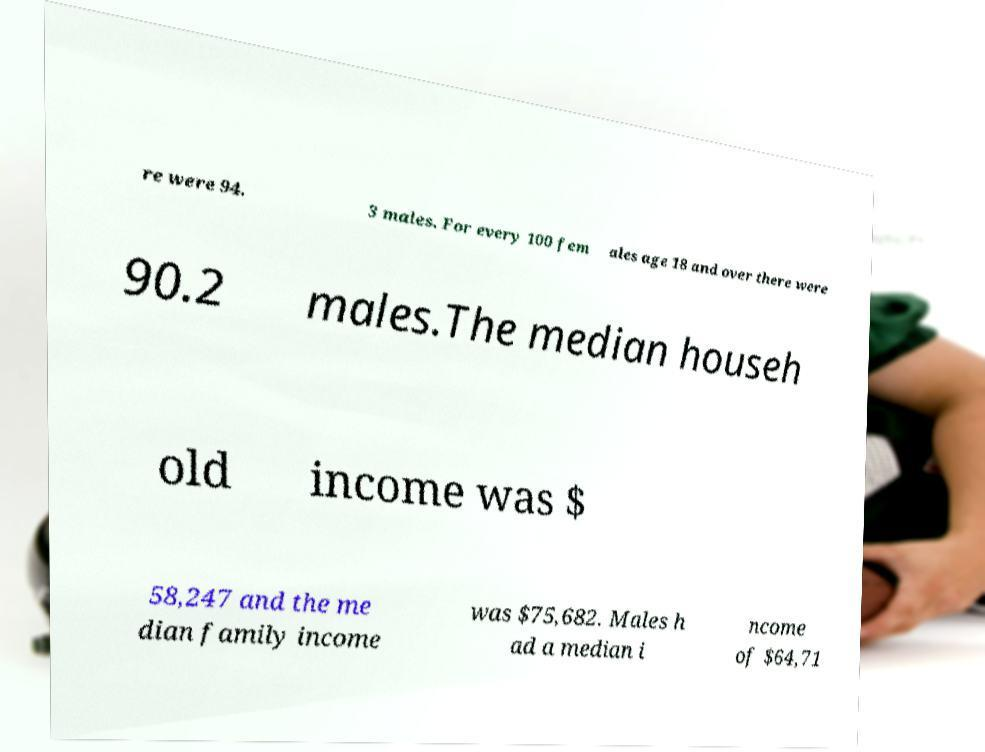There's text embedded in this image that I need extracted. Can you transcribe it verbatim? re were 94. 3 males. For every 100 fem ales age 18 and over there were 90.2 males.The median househ old income was $ 58,247 and the me dian family income was $75,682. Males h ad a median i ncome of $64,71 